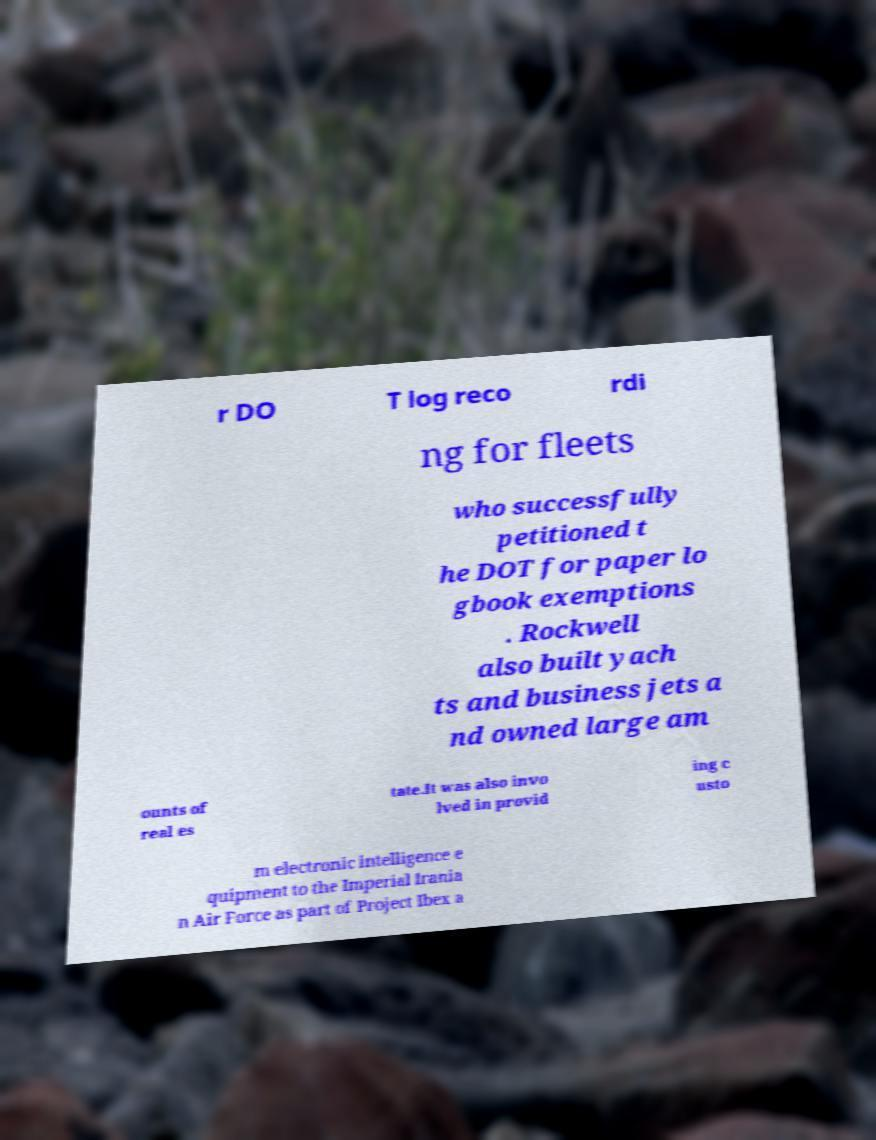Please read and relay the text visible in this image. What does it say? r DO T log reco rdi ng for fleets who successfully petitioned t he DOT for paper lo gbook exemptions . Rockwell also built yach ts and business jets a nd owned large am ounts of real es tate.It was also invo lved in provid ing c usto m electronic intelligence e quipment to the Imperial Irania n Air Force as part of Project Ibex a 